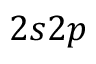Convert formula to latex. <formula><loc_0><loc_0><loc_500><loc_500>2 s 2 p</formula> 